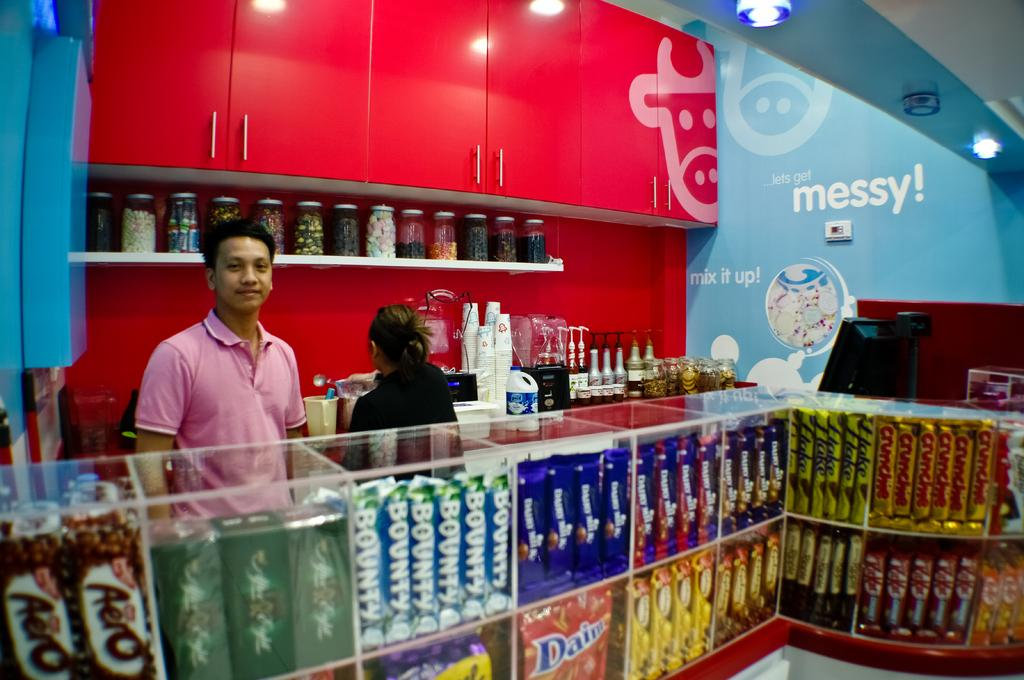<image>
Write a terse but informative summary of the picture. A man standing in front of a display of chocolate with Bounty bars being visible. 